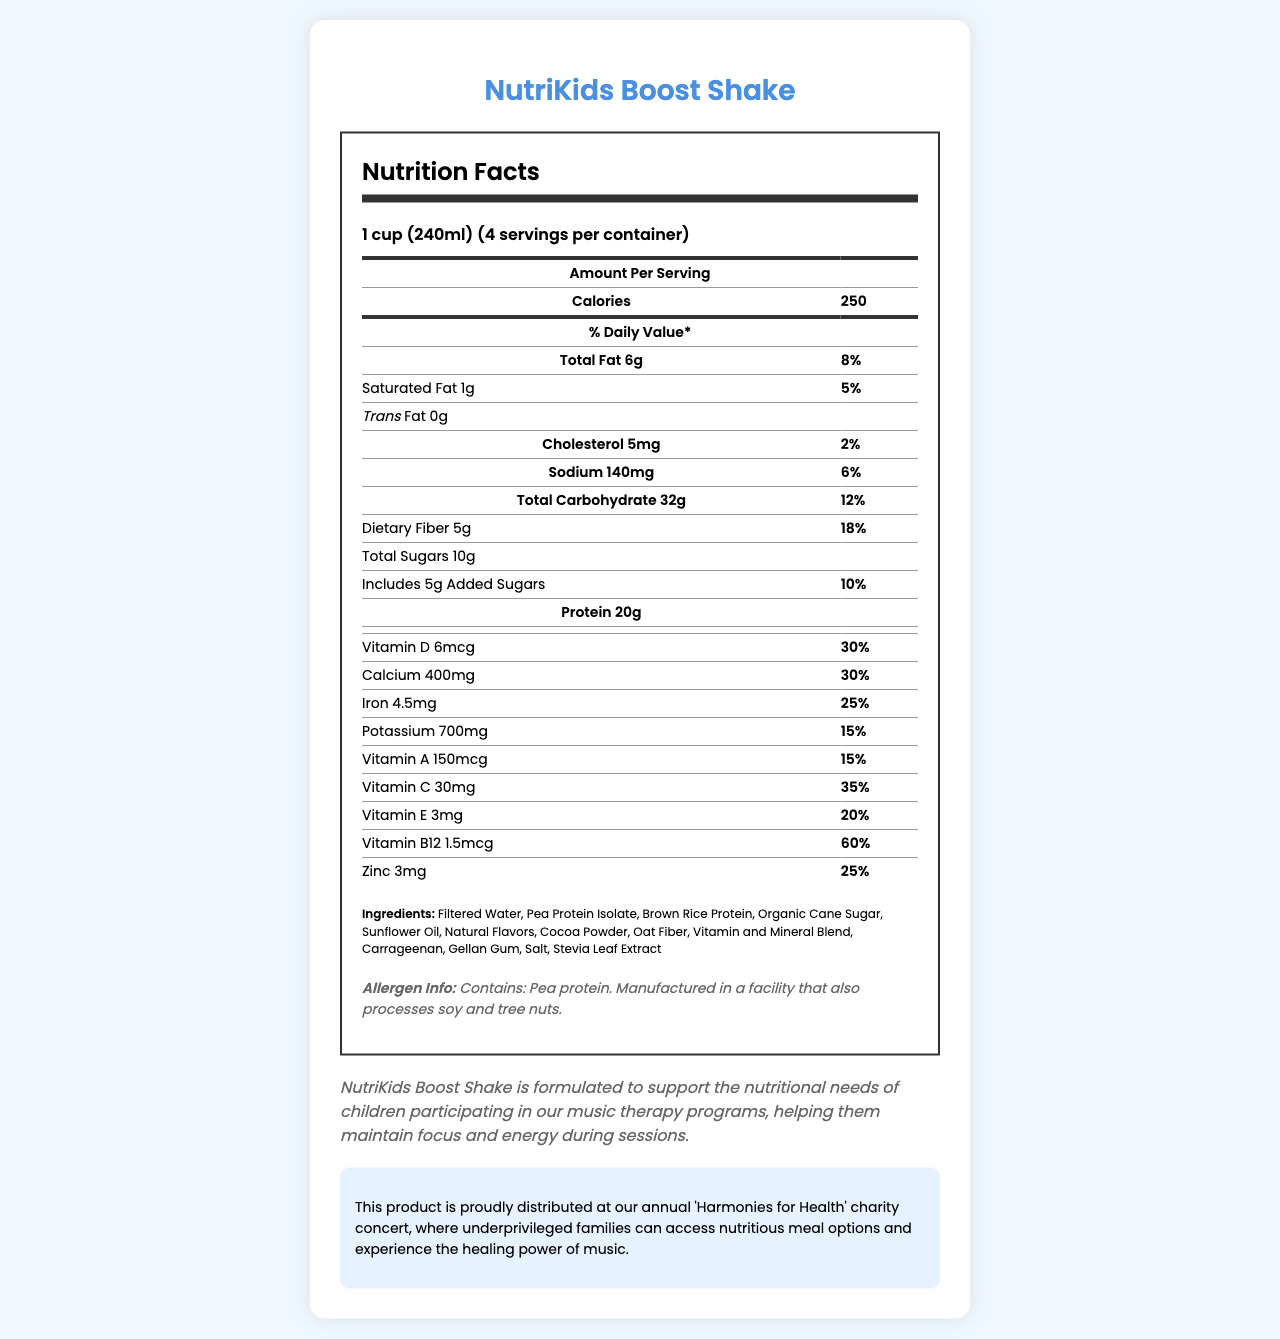What is the serving size for NutriKids Boost Shake? The serving size is explicitly mentioned as 1 cup (240ml).
Answer: 1 cup (240ml) How many servings are in one container of NutriKids Boost Shake? The document states there are 4 servings per container.
Answer: 4 How many calories are in one serving of NutriKids Boost Shake? The calories per serving are listed as 250.
Answer: 250 What is the amount of protein per serving? The amount of protein per serving is shown as 20g.
Answer: 20g What is the daily value percentage of Iron in one serving? The daily value percentage for Iron is indicated as 25%.
Answer: 25% What is the total fat content per serving? The total fat per serving is listed as 6g.
Answer: 6g Which vitamin has the highest daily value percentage in one serving of NutriKids Boost Shake? A. Vitamin A B. Vitamin C C. Vitamin D D. Vitamin B12 Vitamin B12 has the highest daily value percentage at 60%.
Answer: D How much dietary fiber is there in one serving? A. 3g B. 5g C. 7g D. 10g The dietary fiber content per serving is 5g.
Answer: B Is the NutriKids Boost Shake suitable for children who are allergic to peanuts? The allergen Info mentions pea protein and notes it is processed in a facility with soy and tree nuts, but does not specify peanuts.
Answer: Not enough information Does NutriKids Boost Shake contain any trans fat? The document lists Trans Fat as 0g, indicating there is no trans fat.
Answer: No Summarize the main idea of the NutriKids Boost Shake document. The document provides detailed nutrition facts, ingredients, allergen information, and a note on its use in music therapy programs and charity events, emphasizing the product’s benefits and components.
Answer: The NutriKids Boost Shake is a nutritious meal replacement formulated for children, featuring key vitamins and minerals to support nutritional needs during music therapy programs. It contains 250 calories per serving, with a notable 20g of protein and 5g of dietary fiber. The product also emphasizes its distribution at charity events aiming to provide nutritious options to underprivileged families. 